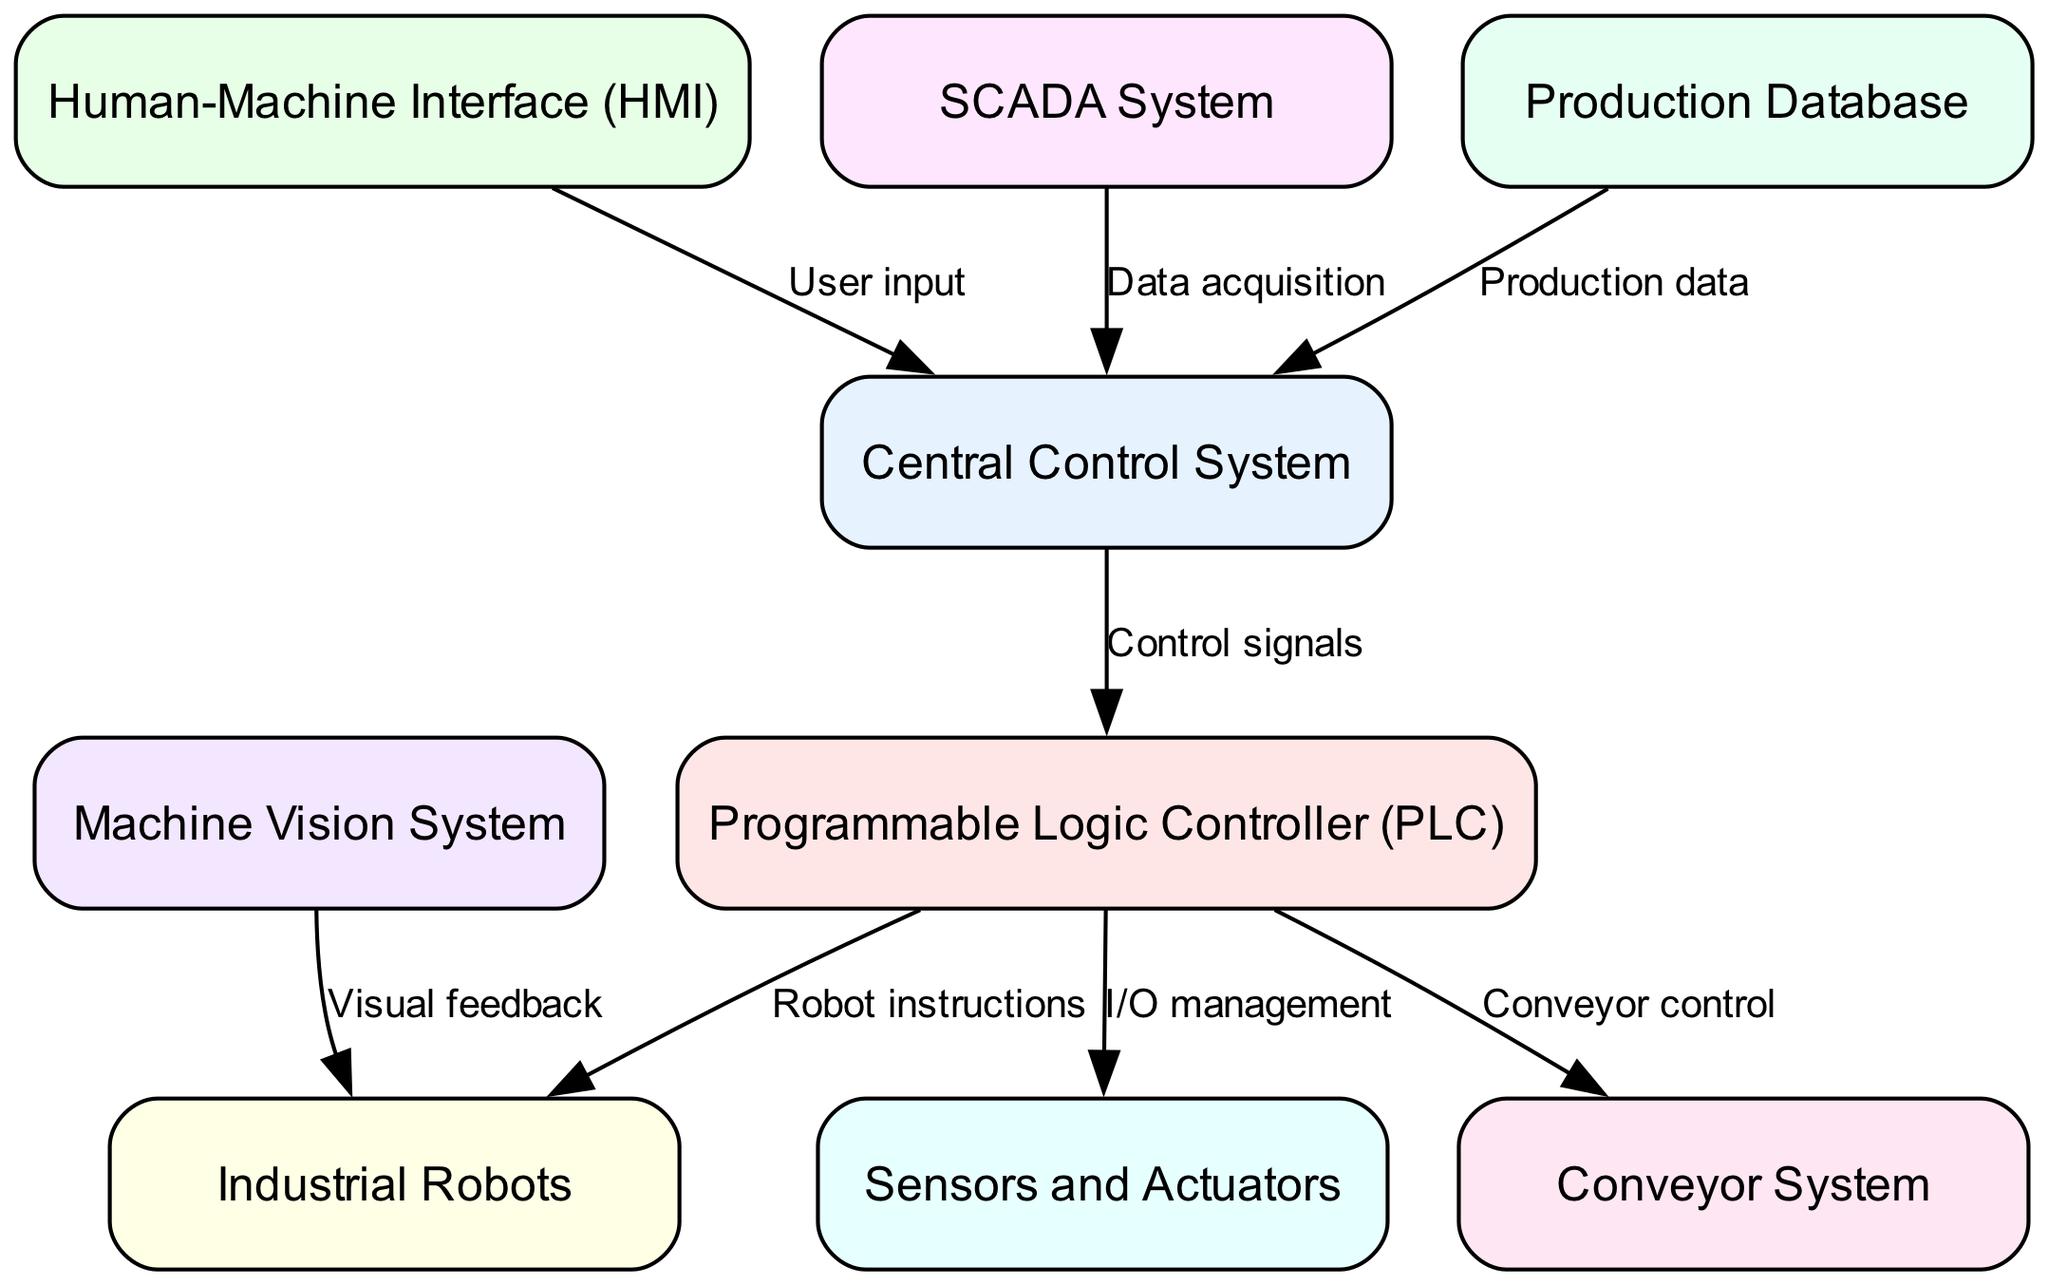What are the nodes in the diagram? The diagram contains several nodes that represent different components of the industrial automation system: Central Control System, Programmable Logic Controller (PLC), Human-Machine Interface (HMI), SCADA System, Industrial Robots, Sensors and Actuators, Conveyor System, Machine Vision System, and Production Database.
Answer: Central Control System, Programmable Logic Controller (PLC), Human-Machine Interface (HMI), SCADA System, Industrial Robots, Sensors and Actuators, Conveyor System, Machine Vision System, Production Database How many edges are there in the diagram? By counting the connections between nodes in the diagram, we find there are a total of 8 edges that illustrate the relationships between the various components.
Answer: 8 What type of signal flows from the Central Control System to the PLC? The edge between the Central Control System and the PLC is labeled "Control signals," indicating that control signals are sent from the Central Control System to manage the PLC.
Answer: Control signals Which node receives visual feedback? The "Industrial Robots" node receives visual feedback from the "Machine Vision System," as indicated by the directed edge connecting these two nodes in the diagram.
Answer: Industrial Robots What is the relationship between the PLC and the Conveyor System? The diagram shows that the PLC sends "Conveyor control" instructions to the Conveyor System, establishing a direct control relationship between these two nodes.
Answer: Conveyor control How does the HMI contribute to the Central Control System? The Human-Machine Interface provides "User input" to the Central Control System, indicating it acts as an interface for operators to input commands or modify parameters within the system.
Answer: User input What data does the Production Database provide to the Control System? The Production Database sends "Production data" to the Central Control System, which is essential for monitoring and controlling the manufacturing processes.
Answer: Production data What is the function of the edge from SCADA to the Control System? The edge from the SCADA System to the Central Control System is labeled "Data acquisition," which means that SCADA collects and provides real-time data pertaining to the manufacturing operations to the Control System for analysis and adjustments.
Answer: Data acquisition Which component is integrated with sensors and actuators for I/O management? The Programmable Logic Controller (PLC) is responsible for I/O management and is connected to the "Sensors and Actuators" node, indicating that it facilitates the input and output operations for the automation system.
Answer: Programmable Logic Controller (PLC) 